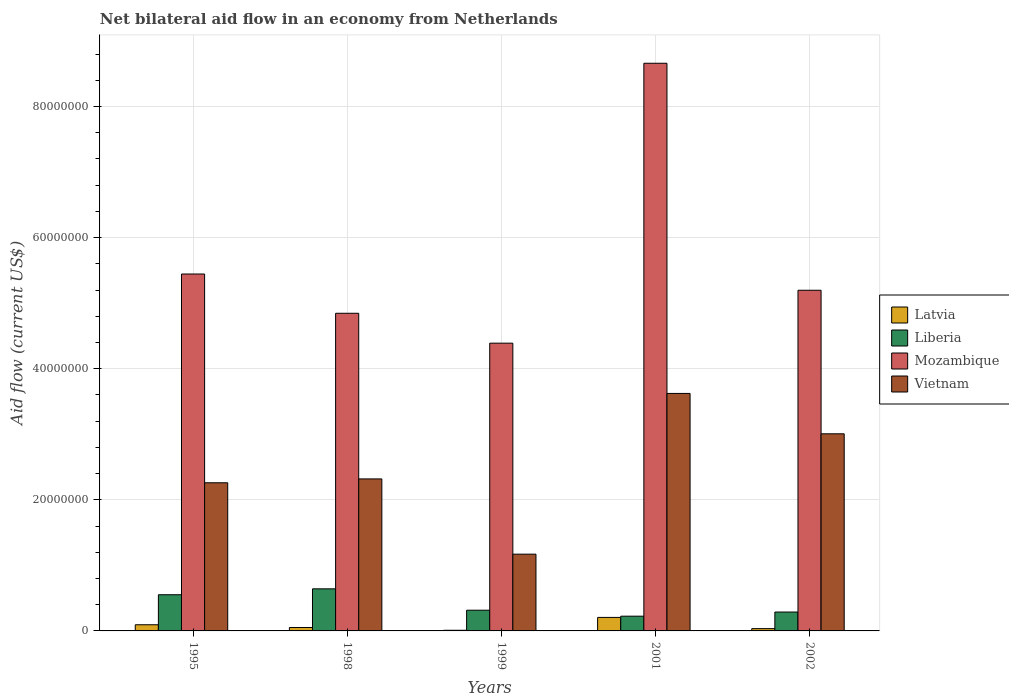Are the number of bars on each tick of the X-axis equal?
Your response must be concise. Yes. How many bars are there on the 2nd tick from the left?
Give a very brief answer. 4. What is the label of the 2nd group of bars from the left?
Ensure brevity in your answer.  1998. What is the net bilateral aid flow in Mozambique in 1998?
Your response must be concise. 4.85e+07. Across all years, what is the maximum net bilateral aid flow in Liberia?
Provide a succinct answer. 6.42e+06. Across all years, what is the minimum net bilateral aid flow in Vietnam?
Give a very brief answer. 1.17e+07. In which year was the net bilateral aid flow in Vietnam maximum?
Offer a terse response. 2001. In which year was the net bilateral aid flow in Liberia minimum?
Give a very brief answer. 2001. What is the total net bilateral aid flow in Vietnam in the graph?
Offer a terse response. 1.24e+08. What is the difference between the net bilateral aid flow in Mozambique in 1998 and that in 2001?
Offer a very short reply. -3.81e+07. What is the difference between the net bilateral aid flow in Mozambique in 1998 and the net bilateral aid flow in Vietnam in 1995?
Provide a short and direct response. 2.59e+07. What is the average net bilateral aid flow in Mozambique per year?
Offer a very short reply. 5.71e+07. In the year 1998, what is the difference between the net bilateral aid flow in Liberia and net bilateral aid flow in Latvia?
Keep it short and to the point. 5.90e+06. What is the ratio of the net bilateral aid flow in Liberia in 1998 to that in 2002?
Offer a terse response. 2.23. Is the net bilateral aid flow in Liberia in 1999 less than that in 2002?
Keep it short and to the point. No. What is the difference between the highest and the second highest net bilateral aid flow in Latvia?
Provide a succinct answer. 1.12e+06. What is the difference between the highest and the lowest net bilateral aid flow in Vietnam?
Make the answer very short. 2.45e+07. In how many years, is the net bilateral aid flow in Latvia greater than the average net bilateral aid flow in Latvia taken over all years?
Make the answer very short. 2. What does the 2nd bar from the left in 1995 represents?
Ensure brevity in your answer.  Liberia. What does the 1st bar from the right in 1995 represents?
Provide a short and direct response. Vietnam. How many bars are there?
Your answer should be compact. 20. Are the values on the major ticks of Y-axis written in scientific E-notation?
Give a very brief answer. No. Where does the legend appear in the graph?
Provide a short and direct response. Center right. How are the legend labels stacked?
Give a very brief answer. Vertical. What is the title of the graph?
Make the answer very short. Net bilateral aid flow in an economy from Netherlands. What is the Aid flow (current US$) in Latvia in 1995?
Ensure brevity in your answer.  9.40e+05. What is the Aid flow (current US$) of Liberia in 1995?
Ensure brevity in your answer.  5.52e+06. What is the Aid flow (current US$) in Mozambique in 1995?
Keep it short and to the point. 5.44e+07. What is the Aid flow (current US$) in Vietnam in 1995?
Make the answer very short. 2.26e+07. What is the Aid flow (current US$) of Latvia in 1998?
Provide a succinct answer. 5.20e+05. What is the Aid flow (current US$) of Liberia in 1998?
Provide a succinct answer. 6.42e+06. What is the Aid flow (current US$) of Mozambique in 1998?
Make the answer very short. 4.85e+07. What is the Aid flow (current US$) in Vietnam in 1998?
Your answer should be very brief. 2.32e+07. What is the Aid flow (current US$) in Liberia in 1999?
Your answer should be very brief. 3.16e+06. What is the Aid flow (current US$) in Mozambique in 1999?
Ensure brevity in your answer.  4.39e+07. What is the Aid flow (current US$) of Vietnam in 1999?
Provide a short and direct response. 1.17e+07. What is the Aid flow (current US$) of Latvia in 2001?
Provide a short and direct response. 2.06e+06. What is the Aid flow (current US$) in Liberia in 2001?
Offer a very short reply. 2.25e+06. What is the Aid flow (current US$) of Mozambique in 2001?
Offer a terse response. 8.66e+07. What is the Aid flow (current US$) in Vietnam in 2001?
Keep it short and to the point. 3.62e+07. What is the Aid flow (current US$) in Latvia in 2002?
Provide a short and direct response. 3.50e+05. What is the Aid flow (current US$) of Liberia in 2002?
Ensure brevity in your answer.  2.88e+06. What is the Aid flow (current US$) of Mozambique in 2002?
Your response must be concise. 5.20e+07. What is the Aid flow (current US$) of Vietnam in 2002?
Provide a succinct answer. 3.01e+07. Across all years, what is the maximum Aid flow (current US$) in Latvia?
Provide a short and direct response. 2.06e+06. Across all years, what is the maximum Aid flow (current US$) in Liberia?
Keep it short and to the point. 6.42e+06. Across all years, what is the maximum Aid flow (current US$) of Mozambique?
Give a very brief answer. 8.66e+07. Across all years, what is the maximum Aid flow (current US$) in Vietnam?
Make the answer very short. 3.62e+07. Across all years, what is the minimum Aid flow (current US$) in Liberia?
Make the answer very short. 2.25e+06. Across all years, what is the minimum Aid flow (current US$) in Mozambique?
Offer a very short reply. 4.39e+07. Across all years, what is the minimum Aid flow (current US$) of Vietnam?
Provide a succinct answer. 1.17e+07. What is the total Aid flow (current US$) of Latvia in the graph?
Your response must be concise. 3.97e+06. What is the total Aid flow (current US$) of Liberia in the graph?
Ensure brevity in your answer.  2.02e+07. What is the total Aid flow (current US$) in Mozambique in the graph?
Provide a short and direct response. 2.85e+08. What is the total Aid flow (current US$) of Vietnam in the graph?
Ensure brevity in your answer.  1.24e+08. What is the difference between the Aid flow (current US$) in Latvia in 1995 and that in 1998?
Your answer should be very brief. 4.20e+05. What is the difference between the Aid flow (current US$) of Liberia in 1995 and that in 1998?
Provide a short and direct response. -9.00e+05. What is the difference between the Aid flow (current US$) in Mozambique in 1995 and that in 1998?
Offer a very short reply. 5.99e+06. What is the difference between the Aid flow (current US$) of Vietnam in 1995 and that in 1998?
Offer a very short reply. -5.90e+05. What is the difference between the Aid flow (current US$) in Latvia in 1995 and that in 1999?
Provide a short and direct response. 8.40e+05. What is the difference between the Aid flow (current US$) in Liberia in 1995 and that in 1999?
Your response must be concise. 2.36e+06. What is the difference between the Aid flow (current US$) in Mozambique in 1995 and that in 1999?
Provide a succinct answer. 1.06e+07. What is the difference between the Aid flow (current US$) of Vietnam in 1995 and that in 1999?
Make the answer very short. 1.09e+07. What is the difference between the Aid flow (current US$) of Latvia in 1995 and that in 2001?
Your answer should be compact. -1.12e+06. What is the difference between the Aid flow (current US$) of Liberia in 1995 and that in 2001?
Give a very brief answer. 3.27e+06. What is the difference between the Aid flow (current US$) of Mozambique in 1995 and that in 2001?
Offer a terse response. -3.22e+07. What is the difference between the Aid flow (current US$) in Vietnam in 1995 and that in 2001?
Your response must be concise. -1.36e+07. What is the difference between the Aid flow (current US$) in Latvia in 1995 and that in 2002?
Provide a short and direct response. 5.90e+05. What is the difference between the Aid flow (current US$) of Liberia in 1995 and that in 2002?
Provide a succinct answer. 2.64e+06. What is the difference between the Aid flow (current US$) in Mozambique in 1995 and that in 2002?
Provide a succinct answer. 2.48e+06. What is the difference between the Aid flow (current US$) of Vietnam in 1995 and that in 2002?
Offer a terse response. -7.47e+06. What is the difference between the Aid flow (current US$) of Latvia in 1998 and that in 1999?
Your answer should be very brief. 4.20e+05. What is the difference between the Aid flow (current US$) of Liberia in 1998 and that in 1999?
Your response must be concise. 3.26e+06. What is the difference between the Aid flow (current US$) in Mozambique in 1998 and that in 1999?
Ensure brevity in your answer.  4.56e+06. What is the difference between the Aid flow (current US$) of Vietnam in 1998 and that in 1999?
Provide a succinct answer. 1.15e+07. What is the difference between the Aid flow (current US$) in Latvia in 1998 and that in 2001?
Provide a succinct answer. -1.54e+06. What is the difference between the Aid flow (current US$) of Liberia in 1998 and that in 2001?
Give a very brief answer. 4.17e+06. What is the difference between the Aid flow (current US$) in Mozambique in 1998 and that in 2001?
Your response must be concise. -3.81e+07. What is the difference between the Aid flow (current US$) in Vietnam in 1998 and that in 2001?
Your answer should be compact. -1.30e+07. What is the difference between the Aid flow (current US$) of Liberia in 1998 and that in 2002?
Offer a terse response. 3.54e+06. What is the difference between the Aid flow (current US$) of Mozambique in 1998 and that in 2002?
Ensure brevity in your answer.  -3.51e+06. What is the difference between the Aid flow (current US$) in Vietnam in 1998 and that in 2002?
Offer a terse response. -6.88e+06. What is the difference between the Aid flow (current US$) of Latvia in 1999 and that in 2001?
Give a very brief answer. -1.96e+06. What is the difference between the Aid flow (current US$) in Liberia in 1999 and that in 2001?
Give a very brief answer. 9.10e+05. What is the difference between the Aid flow (current US$) of Mozambique in 1999 and that in 2001?
Your answer should be very brief. -4.27e+07. What is the difference between the Aid flow (current US$) of Vietnam in 1999 and that in 2001?
Provide a short and direct response. -2.45e+07. What is the difference between the Aid flow (current US$) of Liberia in 1999 and that in 2002?
Give a very brief answer. 2.80e+05. What is the difference between the Aid flow (current US$) in Mozambique in 1999 and that in 2002?
Ensure brevity in your answer.  -8.07e+06. What is the difference between the Aid flow (current US$) of Vietnam in 1999 and that in 2002?
Your answer should be very brief. -1.84e+07. What is the difference between the Aid flow (current US$) in Latvia in 2001 and that in 2002?
Provide a succinct answer. 1.71e+06. What is the difference between the Aid flow (current US$) in Liberia in 2001 and that in 2002?
Offer a very short reply. -6.30e+05. What is the difference between the Aid flow (current US$) of Mozambique in 2001 and that in 2002?
Make the answer very short. 3.46e+07. What is the difference between the Aid flow (current US$) of Vietnam in 2001 and that in 2002?
Offer a very short reply. 6.16e+06. What is the difference between the Aid flow (current US$) in Latvia in 1995 and the Aid flow (current US$) in Liberia in 1998?
Offer a terse response. -5.48e+06. What is the difference between the Aid flow (current US$) in Latvia in 1995 and the Aid flow (current US$) in Mozambique in 1998?
Provide a short and direct response. -4.75e+07. What is the difference between the Aid flow (current US$) in Latvia in 1995 and the Aid flow (current US$) in Vietnam in 1998?
Make the answer very short. -2.22e+07. What is the difference between the Aid flow (current US$) of Liberia in 1995 and the Aid flow (current US$) of Mozambique in 1998?
Provide a succinct answer. -4.29e+07. What is the difference between the Aid flow (current US$) in Liberia in 1995 and the Aid flow (current US$) in Vietnam in 1998?
Provide a succinct answer. -1.77e+07. What is the difference between the Aid flow (current US$) of Mozambique in 1995 and the Aid flow (current US$) of Vietnam in 1998?
Your response must be concise. 3.13e+07. What is the difference between the Aid flow (current US$) in Latvia in 1995 and the Aid flow (current US$) in Liberia in 1999?
Give a very brief answer. -2.22e+06. What is the difference between the Aid flow (current US$) in Latvia in 1995 and the Aid flow (current US$) in Mozambique in 1999?
Keep it short and to the point. -4.30e+07. What is the difference between the Aid flow (current US$) of Latvia in 1995 and the Aid flow (current US$) of Vietnam in 1999?
Keep it short and to the point. -1.08e+07. What is the difference between the Aid flow (current US$) of Liberia in 1995 and the Aid flow (current US$) of Mozambique in 1999?
Keep it short and to the point. -3.84e+07. What is the difference between the Aid flow (current US$) of Liberia in 1995 and the Aid flow (current US$) of Vietnam in 1999?
Ensure brevity in your answer.  -6.19e+06. What is the difference between the Aid flow (current US$) of Mozambique in 1995 and the Aid flow (current US$) of Vietnam in 1999?
Keep it short and to the point. 4.27e+07. What is the difference between the Aid flow (current US$) in Latvia in 1995 and the Aid flow (current US$) in Liberia in 2001?
Give a very brief answer. -1.31e+06. What is the difference between the Aid flow (current US$) of Latvia in 1995 and the Aid flow (current US$) of Mozambique in 2001?
Your response must be concise. -8.57e+07. What is the difference between the Aid flow (current US$) of Latvia in 1995 and the Aid flow (current US$) of Vietnam in 2001?
Your response must be concise. -3.53e+07. What is the difference between the Aid flow (current US$) of Liberia in 1995 and the Aid flow (current US$) of Mozambique in 2001?
Your response must be concise. -8.11e+07. What is the difference between the Aid flow (current US$) of Liberia in 1995 and the Aid flow (current US$) of Vietnam in 2001?
Provide a short and direct response. -3.07e+07. What is the difference between the Aid flow (current US$) in Mozambique in 1995 and the Aid flow (current US$) in Vietnam in 2001?
Provide a short and direct response. 1.82e+07. What is the difference between the Aid flow (current US$) of Latvia in 1995 and the Aid flow (current US$) of Liberia in 2002?
Give a very brief answer. -1.94e+06. What is the difference between the Aid flow (current US$) in Latvia in 1995 and the Aid flow (current US$) in Mozambique in 2002?
Your answer should be very brief. -5.10e+07. What is the difference between the Aid flow (current US$) of Latvia in 1995 and the Aid flow (current US$) of Vietnam in 2002?
Make the answer very short. -2.91e+07. What is the difference between the Aid flow (current US$) in Liberia in 1995 and the Aid flow (current US$) in Mozambique in 2002?
Give a very brief answer. -4.64e+07. What is the difference between the Aid flow (current US$) in Liberia in 1995 and the Aid flow (current US$) in Vietnam in 2002?
Make the answer very short. -2.46e+07. What is the difference between the Aid flow (current US$) in Mozambique in 1995 and the Aid flow (current US$) in Vietnam in 2002?
Make the answer very short. 2.44e+07. What is the difference between the Aid flow (current US$) of Latvia in 1998 and the Aid flow (current US$) of Liberia in 1999?
Keep it short and to the point. -2.64e+06. What is the difference between the Aid flow (current US$) of Latvia in 1998 and the Aid flow (current US$) of Mozambique in 1999?
Your answer should be compact. -4.34e+07. What is the difference between the Aid flow (current US$) of Latvia in 1998 and the Aid flow (current US$) of Vietnam in 1999?
Your response must be concise. -1.12e+07. What is the difference between the Aid flow (current US$) in Liberia in 1998 and the Aid flow (current US$) in Mozambique in 1999?
Provide a succinct answer. -3.75e+07. What is the difference between the Aid flow (current US$) of Liberia in 1998 and the Aid flow (current US$) of Vietnam in 1999?
Offer a very short reply. -5.29e+06. What is the difference between the Aid flow (current US$) in Mozambique in 1998 and the Aid flow (current US$) in Vietnam in 1999?
Your answer should be very brief. 3.68e+07. What is the difference between the Aid flow (current US$) of Latvia in 1998 and the Aid flow (current US$) of Liberia in 2001?
Offer a terse response. -1.73e+06. What is the difference between the Aid flow (current US$) in Latvia in 1998 and the Aid flow (current US$) in Mozambique in 2001?
Provide a short and direct response. -8.61e+07. What is the difference between the Aid flow (current US$) in Latvia in 1998 and the Aid flow (current US$) in Vietnam in 2001?
Provide a succinct answer. -3.57e+07. What is the difference between the Aid flow (current US$) of Liberia in 1998 and the Aid flow (current US$) of Mozambique in 2001?
Keep it short and to the point. -8.02e+07. What is the difference between the Aid flow (current US$) of Liberia in 1998 and the Aid flow (current US$) of Vietnam in 2001?
Your answer should be very brief. -2.98e+07. What is the difference between the Aid flow (current US$) of Mozambique in 1998 and the Aid flow (current US$) of Vietnam in 2001?
Ensure brevity in your answer.  1.22e+07. What is the difference between the Aid flow (current US$) of Latvia in 1998 and the Aid flow (current US$) of Liberia in 2002?
Keep it short and to the point. -2.36e+06. What is the difference between the Aid flow (current US$) of Latvia in 1998 and the Aid flow (current US$) of Mozambique in 2002?
Offer a terse response. -5.14e+07. What is the difference between the Aid flow (current US$) in Latvia in 1998 and the Aid flow (current US$) in Vietnam in 2002?
Your answer should be very brief. -2.96e+07. What is the difference between the Aid flow (current US$) in Liberia in 1998 and the Aid flow (current US$) in Mozambique in 2002?
Your answer should be compact. -4.56e+07. What is the difference between the Aid flow (current US$) of Liberia in 1998 and the Aid flow (current US$) of Vietnam in 2002?
Offer a very short reply. -2.36e+07. What is the difference between the Aid flow (current US$) in Mozambique in 1998 and the Aid flow (current US$) in Vietnam in 2002?
Provide a short and direct response. 1.84e+07. What is the difference between the Aid flow (current US$) in Latvia in 1999 and the Aid flow (current US$) in Liberia in 2001?
Make the answer very short. -2.15e+06. What is the difference between the Aid flow (current US$) in Latvia in 1999 and the Aid flow (current US$) in Mozambique in 2001?
Provide a short and direct response. -8.65e+07. What is the difference between the Aid flow (current US$) in Latvia in 1999 and the Aid flow (current US$) in Vietnam in 2001?
Ensure brevity in your answer.  -3.61e+07. What is the difference between the Aid flow (current US$) of Liberia in 1999 and the Aid flow (current US$) of Mozambique in 2001?
Provide a succinct answer. -8.34e+07. What is the difference between the Aid flow (current US$) of Liberia in 1999 and the Aid flow (current US$) of Vietnam in 2001?
Your answer should be very brief. -3.31e+07. What is the difference between the Aid flow (current US$) of Mozambique in 1999 and the Aid flow (current US$) of Vietnam in 2001?
Keep it short and to the point. 7.67e+06. What is the difference between the Aid flow (current US$) in Latvia in 1999 and the Aid flow (current US$) in Liberia in 2002?
Make the answer very short. -2.78e+06. What is the difference between the Aid flow (current US$) of Latvia in 1999 and the Aid flow (current US$) of Mozambique in 2002?
Offer a terse response. -5.19e+07. What is the difference between the Aid flow (current US$) in Latvia in 1999 and the Aid flow (current US$) in Vietnam in 2002?
Provide a short and direct response. -3.00e+07. What is the difference between the Aid flow (current US$) in Liberia in 1999 and the Aid flow (current US$) in Mozambique in 2002?
Provide a short and direct response. -4.88e+07. What is the difference between the Aid flow (current US$) of Liberia in 1999 and the Aid flow (current US$) of Vietnam in 2002?
Offer a very short reply. -2.69e+07. What is the difference between the Aid flow (current US$) in Mozambique in 1999 and the Aid flow (current US$) in Vietnam in 2002?
Offer a very short reply. 1.38e+07. What is the difference between the Aid flow (current US$) in Latvia in 2001 and the Aid flow (current US$) in Liberia in 2002?
Your response must be concise. -8.20e+05. What is the difference between the Aid flow (current US$) of Latvia in 2001 and the Aid flow (current US$) of Mozambique in 2002?
Offer a terse response. -4.99e+07. What is the difference between the Aid flow (current US$) of Latvia in 2001 and the Aid flow (current US$) of Vietnam in 2002?
Offer a very short reply. -2.80e+07. What is the difference between the Aid flow (current US$) of Liberia in 2001 and the Aid flow (current US$) of Mozambique in 2002?
Offer a very short reply. -4.97e+07. What is the difference between the Aid flow (current US$) in Liberia in 2001 and the Aid flow (current US$) in Vietnam in 2002?
Your response must be concise. -2.78e+07. What is the difference between the Aid flow (current US$) of Mozambique in 2001 and the Aid flow (current US$) of Vietnam in 2002?
Provide a succinct answer. 5.65e+07. What is the average Aid flow (current US$) in Latvia per year?
Your response must be concise. 7.94e+05. What is the average Aid flow (current US$) in Liberia per year?
Offer a very short reply. 4.05e+06. What is the average Aid flow (current US$) of Mozambique per year?
Provide a succinct answer. 5.71e+07. What is the average Aid flow (current US$) in Vietnam per year?
Offer a very short reply. 2.48e+07. In the year 1995, what is the difference between the Aid flow (current US$) in Latvia and Aid flow (current US$) in Liberia?
Provide a short and direct response. -4.58e+06. In the year 1995, what is the difference between the Aid flow (current US$) of Latvia and Aid flow (current US$) of Mozambique?
Keep it short and to the point. -5.35e+07. In the year 1995, what is the difference between the Aid flow (current US$) of Latvia and Aid flow (current US$) of Vietnam?
Offer a very short reply. -2.17e+07. In the year 1995, what is the difference between the Aid flow (current US$) in Liberia and Aid flow (current US$) in Mozambique?
Your response must be concise. -4.89e+07. In the year 1995, what is the difference between the Aid flow (current US$) of Liberia and Aid flow (current US$) of Vietnam?
Your answer should be compact. -1.71e+07. In the year 1995, what is the difference between the Aid flow (current US$) of Mozambique and Aid flow (current US$) of Vietnam?
Your answer should be very brief. 3.18e+07. In the year 1998, what is the difference between the Aid flow (current US$) in Latvia and Aid flow (current US$) in Liberia?
Your answer should be very brief. -5.90e+06. In the year 1998, what is the difference between the Aid flow (current US$) of Latvia and Aid flow (current US$) of Mozambique?
Provide a short and direct response. -4.79e+07. In the year 1998, what is the difference between the Aid flow (current US$) of Latvia and Aid flow (current US$) of Vietnam?
Make the answer very short. -2.27e+07. In the year 1998, what is the difference between the Aid flow (current US$) of Liberia and Aid flow (current US$) of Mozambique?
Provide a short and direct response. -4.20e+07. In the year 1998, what is the difference between the Aid flow (current US$) in Liberia and Aid flow (current US$) in Vietnam?
Give a very brief answer. -1.68e+07. In the year 1998, what is the difference between the Aid flow (current US$) in Mozambique and Aid flow (current US$) in Vietnam?
Give a very brief answer. 2.53e+07. In the year 1999, what is the difference between the Aid flow (current US$) of Latvia and Aid flow (current US$) of Liberia?
Offer a terse response. -3.06e+06. In the year 1999, what is the difference between the Aid flow (current US$) in Latvia and Aid flow (current US$) in Mozambique?
Offer a very short reply. -4.38e+07. In the year 1999, what is the difference between the Aid flow (current US$) in Latvia and Aid flow (current US$) in Vietnam?
Provide a succinct answer. -1.16e+07. In the year 1999, what is the difference between the Aid flow (current US$) in Liberia and Aid flow (current US$) in Mozambique?
Give a very brief answer. -4.07e+07. In the year 1999, what is the difference between the Aid flow (current US$) in Liberia and Aid flow (current US$) in Vietnam?
Give a very brief answer. -8.55e+06. In the year 1999, what is the difference between the Aid flow (current US$) in Mozambique and Aid flow (current US$) in Vietnam?
Offer a terse response. 3.22e+07. In the year 2001, what is the difference between the Aid flow (current US$) of Latvia and Aid flow (current US$) of Liberia?
Ensure brevity in your answer.  -1.90e+05. In the year 2001, what is the difference between the Aid flow (current US$) of Latvia and Aid flow (current US$) of Mozambique?
Your answer should be very brief. -8.45e+07. In the year 2001, what is the difference between the Aid flow (current US$) in Latvia and Aid flow (current US$) in Vietnam?
Your response must be concise. -3.42e+07. In the year 2001, what is the difference between the Aid flow (current US$) in Liberia and Aid flow (current US$) in Mozambique?
Ensure brevity in your answer.  -8.44e+07. In the year 2001, what is the difference between the Aid flow (current US$) of Liberia and Aid flow (current US$) of Vietnam?
Offer a terse response. -3.40e+07. In the year 2001, what is the difference between the Aid flow (current US$) of Mozambique and Aid flow (current US$) of Vietnam?
Provide a succinct answer. 5.04e+07. In the year 2002, what is the difference between the Aid flow (current US$) of Latvia and Aid flow (current US$) of Liberia?
Ensure brevity in your answer.  -2.53e+06. In the year 2002, what is the difference between the Aid flow (current US$) in Latvia and Aid flow (current US$) in Mozambique?
Provide a short and direct response. -5.16e+07. In the year 2002, what is the difference between the Aid flow (current US$) in Latvia and Aid flow (current US$) in Vietnam?
Provide a succinct answer. -2.97e+07. In the year 2002, what is the difference between the Aid flow (current US$) of Liberia and Aid flow (current US$) of Mozambique?
Keep it short and to the point. -4.91e+07. In the year 2002, what is the difference between the Aid flow (current US$) of Liberia and Aid flow (current US$) of Vietnam?
Give a very brief answer. -2.72e+07. In the year 2002, what is the difference between the Aid flow (current US$) of Mozambique and Aid flow (current US$) of Vietnam?
Your response must be concise. 2.19e+07. What is the ratio of the Aid flow (current US$) in Latvia in 1995 to that in 1998?
Your answer should be compact. 1.81. What is the ratio of the Aid flow (current US$) in Liberia in 1995 to that in 1998?
Provide a short and direct response. 0.86. What is the ratio of the Aid flow (current US$) of Mozambique in 1995 to that in 1998?
Ensure brevity in your answer.  1.12. What is the ratio of the Aid flow (current US$) in Vietnam in 1995 to that in 1998?
Your response must be concise. 0.97. What is the ratio of the Aid flow (current US$) of Liberia in 1995 to that in 1999?
Offer a terse response. 1.75. What is the ratio of the Aid flow (current US$) in Mozambique in 1995 to that in 1999?
Your response must be concise. 1.24. What is the ratio of the Aid flow (current US$) in Vietnam in 1995 to that in 1999?
Offer a terse response. 1.93. What is the ratio of the Aid flow (current US$) in Latvia in 1995 to that in 2001?
Give a very brief answer. 0.46. What is the ratio of the Aid flow (current US$) of Liberia in 1995 to that in 2001?
Make the answer very short. 2.45. What is the ratio of the Aid flow (current US$) of Mozambique in 1995 to that in 2001?
Provide a short and direct response. 0.63. What is the ratio of the Aid flow (current US$) in Vietnam in 1995 to that in 2001?
Keep it short and to the point. 0.62. What is the ratio of the Aid flow (current US$) of Latvia in 1995 to that in 2002?
Your response must be concise. 2.69. What is the ratio of the Aid flow (current US$) in Liberia in 1995 to that in 2002?
Your answer should be very brief. 1.92. What is the ratio of the Aid flow (current US$) in Mozambique in 1995 to that in 2002?
Make the answer very short. 1.05. What is the ratio of the Aid flow (current US$) in Vietnam in 1995 to that in 2002?
Give a very brief answer. 0.75. What is the ratio of the Aid flow (current US$) of Liberia in 1998 to that in 1999?
Ensure brevity in your answer.  2.03. What is the ratio of the Aid flow (current US$) in Mozambique in 1998 to that in 1999?
Your answer should be compact. 1.1. What is the ratio of the Aid flow (current US$) in Vietnam in 1998 to that in 1999?
Ensure brevity in your answer.  1.98. What is the ratio of the Aid flow (current US$) of Latvia in 1998 to that in 2001?
Ensure brevity in your answer.  0.25. What is the ratio of the Aid flow (current US$) in Liberia in 1998 to that in 2001?
Provide a short and direct response. 2.85. What is the ratio of the Aid flow (current US$) in Mozambique in 1998 to that in 2001?
Provide a succinct answer. 0.56. What is the ratio of the Aid flow (current US$) of Vietnam in 1998 to that in 2001?
Provide a short and direct response. 0.64. What is the ratio of the Aid flow (current US$) in Latvia in 1998 to that in 2002?
Offer a very short reply. 1.49. What is the ratio of the Aid flow (current US$) of Liberia in 1998 to that in 2002?
Your answer should be very brief. 2.23. What is the ratio of the Aid flow (current US$) in Mozambique in 1998 to that in 2002?
Offer a very short reply. 0.93. What is the ratio of the Aid flow (current US$) of Vietnam in 1998 to that in 2002?
Make the answer very short. 0.77. What is the ratio of the Aid flow (current US$) of Latvia in 1999 to that in 2001?
Your answer should be compact. 0.05. What is the ratio of the Aid flow (current US$) in Liberia in 1999 to that in 2001?
Ensure brevity in your answer.  1.4. What is the ratio of the Aid flow (current US$) of Mozambique in 1999 to that in 2001?
Ensure brevity in your answer.  0.51. What is the ratio of the Aid flow (current US$) of Vietnam in 1999 to that in 2001?
Provide a short and direct response. 0.32. What is the ratio of the Aid flow (current US$) of Latvia in 1999 to that in 2002?
Provide a succinct answer. 0.29. What is the ratio of the Aid flow (current US$) of Liberia in 1999 to that in 2002?
Provide a succinct answer. 1.1. What is the ratio of the Aid flow (current US$) of Mozambique in 1999 to that in 2002?
Provide a short and direct response. 0.84. What is the ratio of the Aid flow (current US$) in Vietnam in 1999 to that in 2002?
Your answer should be compact. 0.39. What is the ratio of the Aid flow (current US$) in Latvia in 2001 to that in 2002?
Your response must be concise. 5.89. What is the ratio of the Aid flow (current US$) of Liberia in 2001 to that in 2002?
Offer a terse response. 0.78. What is the ratio of the Aid flow (current US$) of Mozambique in 2001 to that in 2002?
Your answer should be compact. 1.67. What is the ratio of the Aid flow (current US$) in Vietnam in 2001 to that in 2002?
Provide a succinct answer. 1.2. What is the difference between the highest and the second highest Aid flow (current US$) in Latvia?
Offer a terse response. 1.12e+06. What is the difference between the highest and the second highest Aid flow (current US$) of Mozambique?
Keep it short and to the point. 3.22e+07. What is the difference between the highest and the second highest Aid flow (current US$) of Vietnam?
Offer a very short reply. 6.16e+06. What is the difference between the highest and the lowest Aid flow (current US$) of Latvia?
Ensure brevity in your answer.  1.96e+06. What is the difference between the highest and the lowest Aid flow (current US$) in Liberia?
Your answer should be very brief. 4.17e+06. What is the difference between the highest and the lowest Aid flow (current US$) in Mozambique?
Your answer should be very brief. 4.27e+07. What is the difference between the highest and the lowest Aid flow (current US$) of Vietnam?
Give a very brief answer. 2.45e+07. 